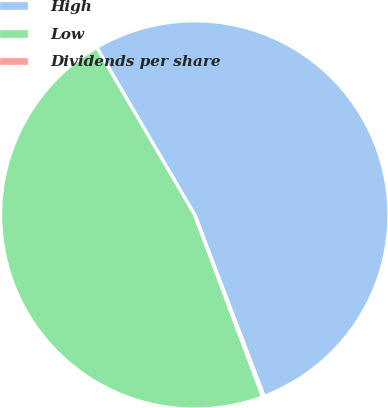Convert chart to OTSL. <chart><loc_0><loc_0><loc_500><loc_500><pie_chart><fcel>High<fcel>Low<fcel>Dividends per share<nl><fcel>52.62%<fcel>47.26%<fcel>0.12%<nl></chart> 